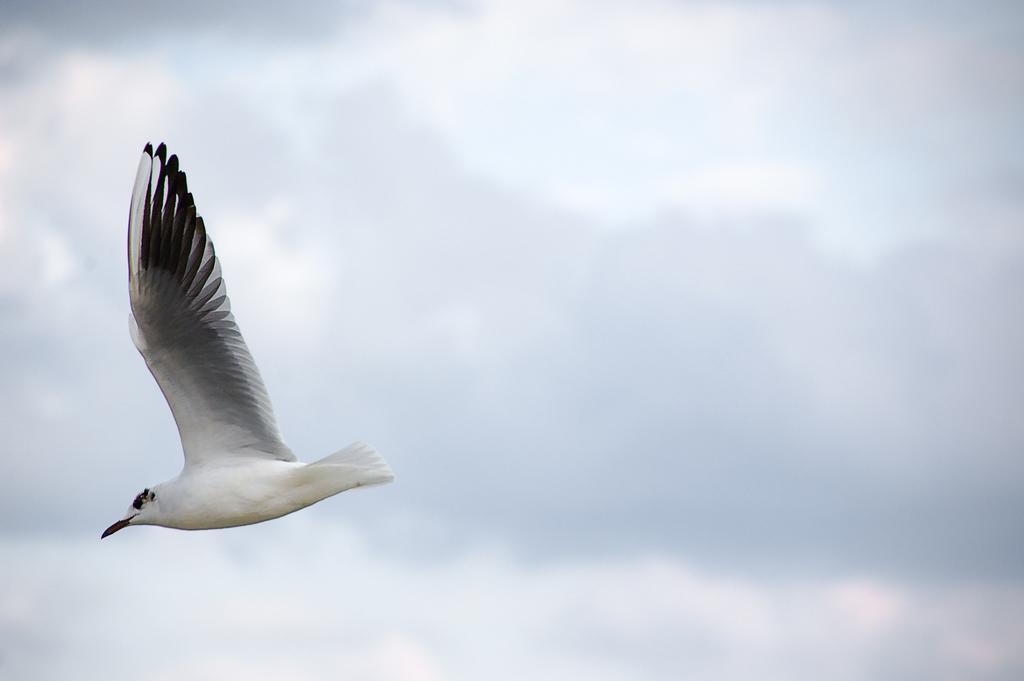How would you summarize this image in a sentence or two? In the image we can see there is a bird flying in the sky. 